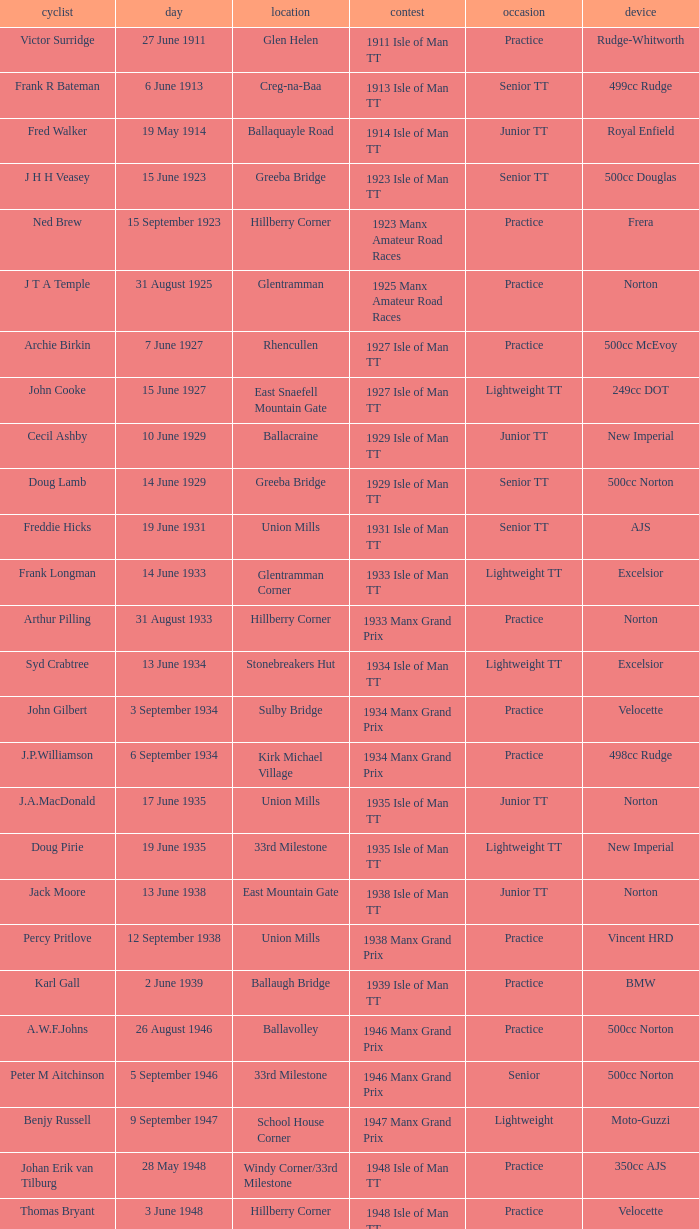What machine did Kenneth E. Herbert ride? 499cc Norton. 